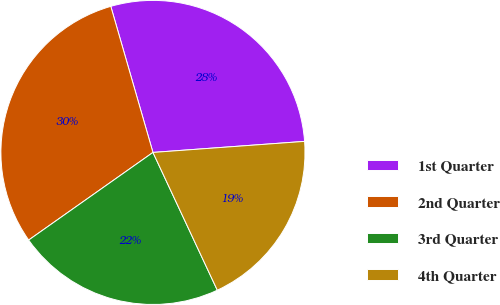Convert chart to OTSL. <chart><loc_0><loc_0><loc_500><loc_500><pie_chart><fcel>1st Quarter<fcel>2nd Quarter<fcel>3rd Quarter<fcel>4th Quarter<nl><fcel>28.31%<fcel>30.3%<fcel>22.18%<fcel>19.2%<nl></chart> 